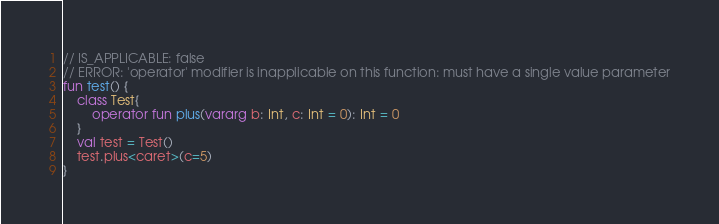<code> <loc_0><loc_0><loc_500><loc_500><_Kotlin_>// IS_APPLICABLE: false
// ERROR: 'operator' modifier is inapplicable on this function: must have a single value parameter
fun test() {
    class Test{
        operator fun plus(vararg b: Int, c: Int = 0): Int = 0
    }
    val test = Test()
    test.plus<caret>(c=5)
}
</code> 